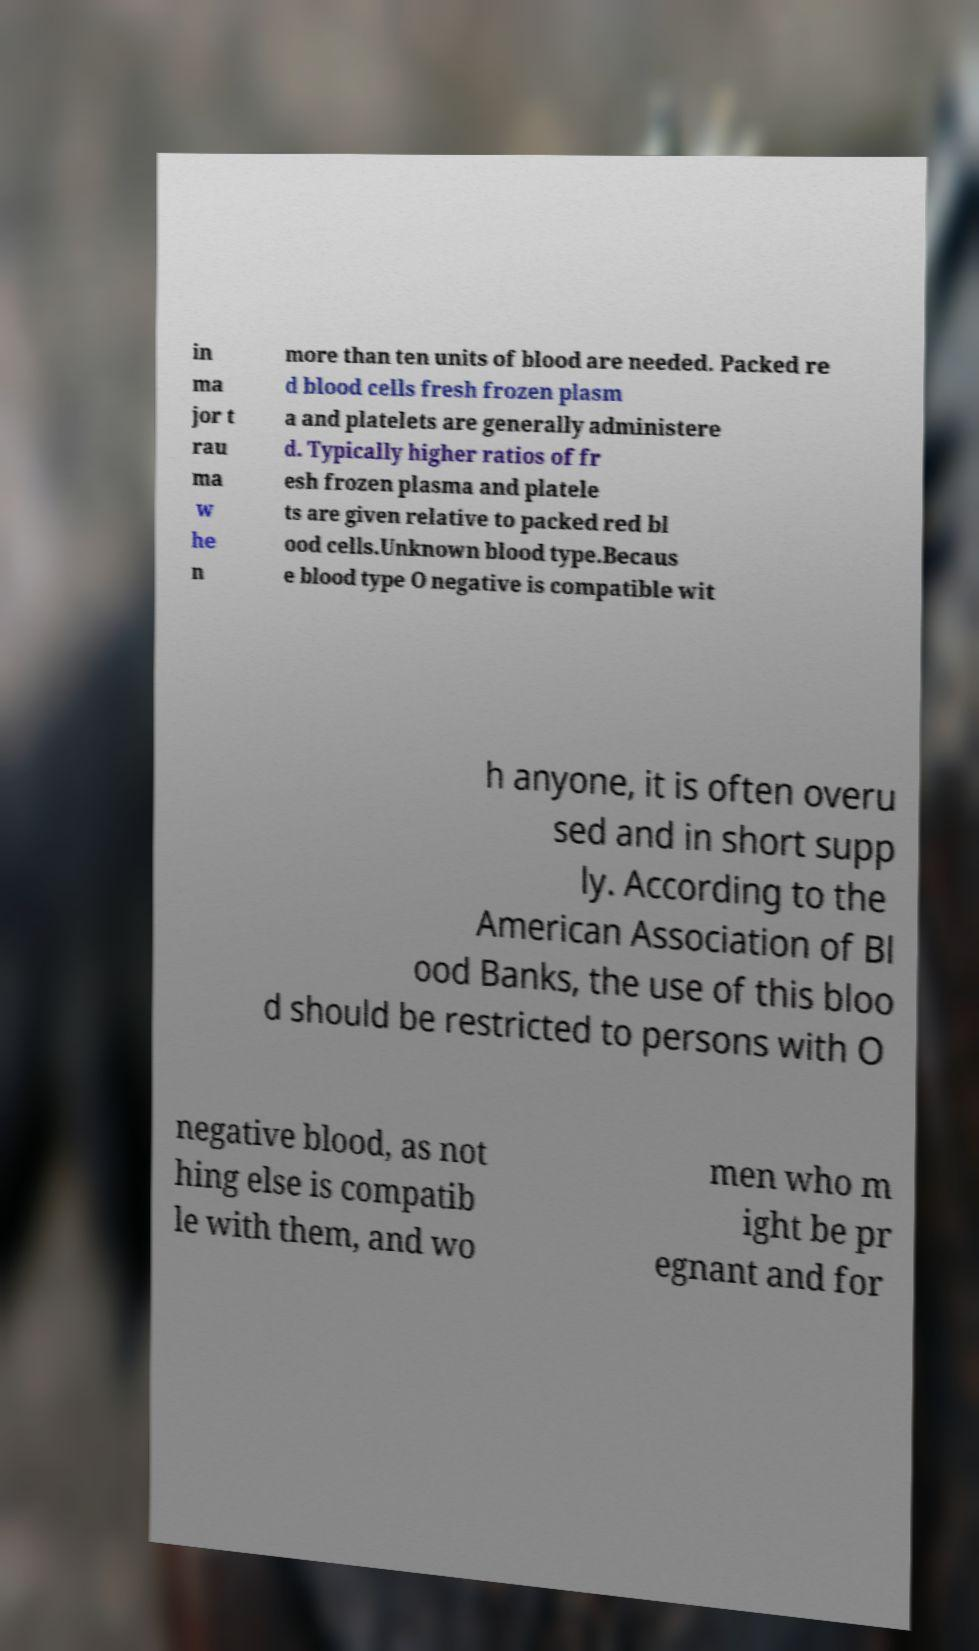Can you accurately transcribe the text from the provided image for me? in ma jor t rau ma w he n more than ten units of blood are needed. Packed re d blood cells fresh frozen plasm a and platelets are generally administere d. Typically higher ratios of fr esh frozen plasma and platele ts are given relative to packed red bl ood cells.Unknown blood type.Becaus e blood type O negative is compatible wit h anyone, it is often overu sed and in short supp ly. According to the American Association of Bl ood Banks, the use of this bloo d should be restricted to persons with O negative blood, as not hing else is compatib le with them, and wo men who m ight be pr egnant and for 